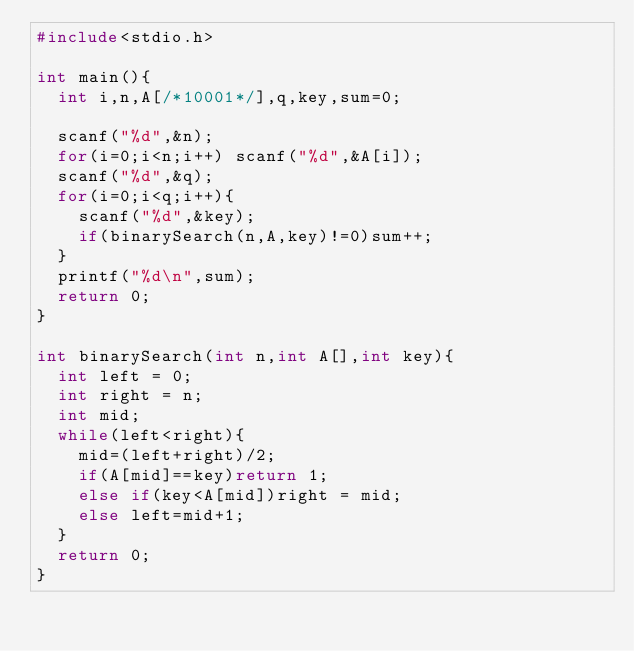Convert code to text. <code><loc_0><loc_0><loc_500><loc_500><_C_>#include<stdio.h>

int main(){
  int i,n,A[/*10001*/],q,key,sum=0;

  scanf("%d",&n);
  for(i=0;i<n;i++) scanf("%d",&A[i]);
  scanf("%d",&q);
  for(i=0;i<q;i++){
    scanf("%d",&key);
    if(binarySearch(n,A,key)!=0)sum++;
  }
  printf("%d\n",sum);
  return 0;
}

int binarySearch(int n,int A[],int key){
  int left = 0;
  int right = n;
  int mid;
  while(left<right){
    mid=(left+right)/2;
    if(A[mid]==key)return 1;
    else if(key<A[mid])right = mid;
    else left=mid+1;
  }
  return 0;
}</code> 